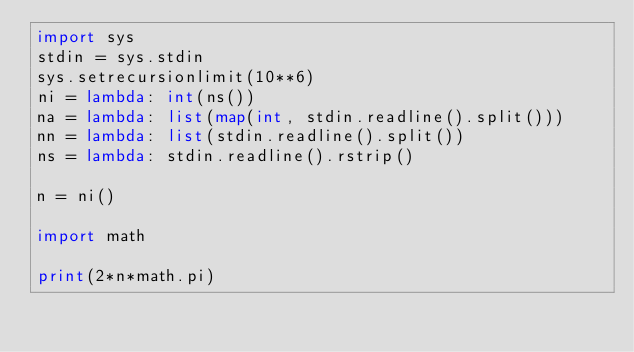Convert code to text. <code><loc_0><loc_0><loc_500><loc_500><_Python_>import sys
stdin = sys.stdin
sys.setrecursionlimit(10**6)
ni = lambda: int(ns())
na = lambda: list(map(int, stdin.readline().split()))
nn = lambda: list(stdin.readline().split())
ns = lambda: stdin.readline().rstrip()

n = ni()

import math

print(2*n*math.pi)</code> 